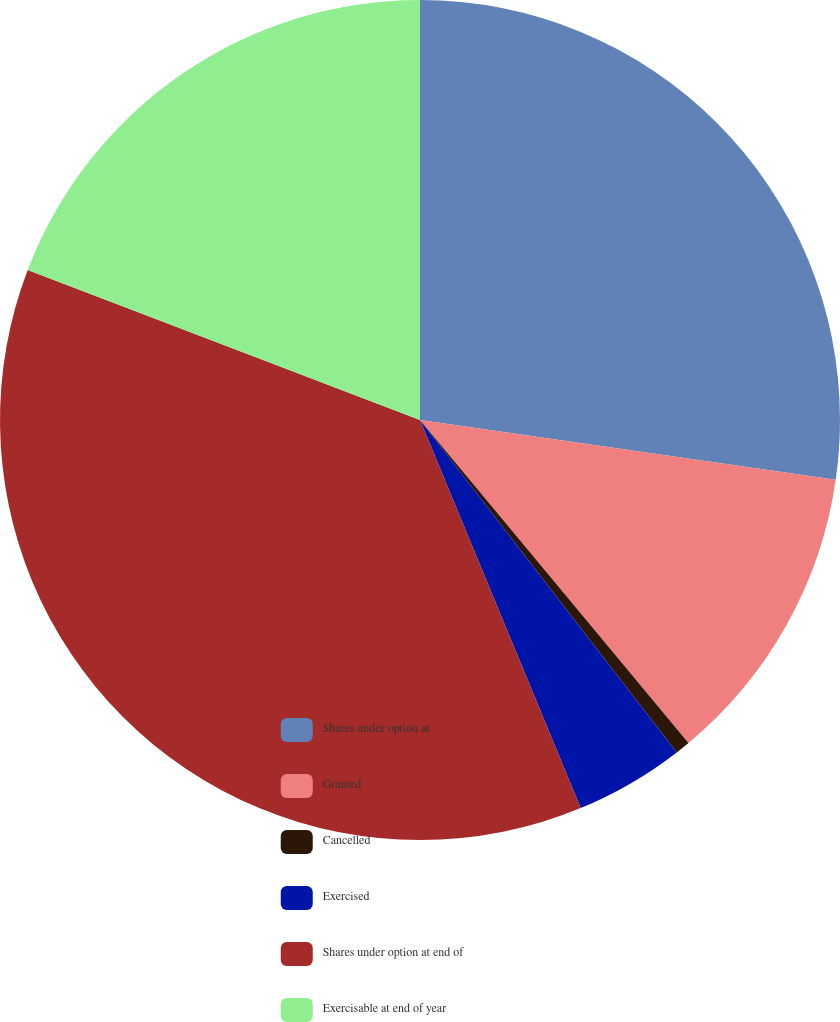Convert chart. <chart><loc_0><loc_0><loc_500><loc_500><pie_chart><fcel>Shares under option at<fcel>Granted<fcel>Cancelled<fcel>Exercised<fcel>Shares under option at end of<fcel>Exercisable at end of year<nl><fcel>27.28%<fcel>11.69%<fcel>0.57%<fcel>4.22%<fcel>37.07%<fcel>19.19%<nl></chart> 